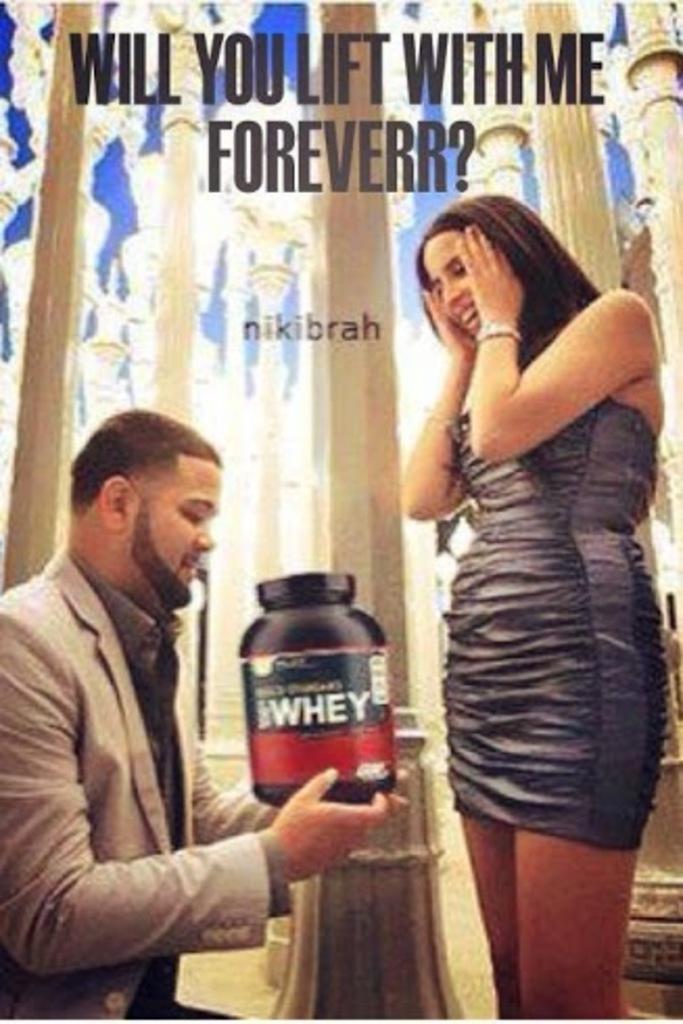Please provide a concise description of this image. In this image I can see a person wearing grey colored jacket and black shirt is holding a black colored object in his hand and a woman wearing black colored dress is standing in front of him. In the background I can see the sky and few pillars which are cream in color. 